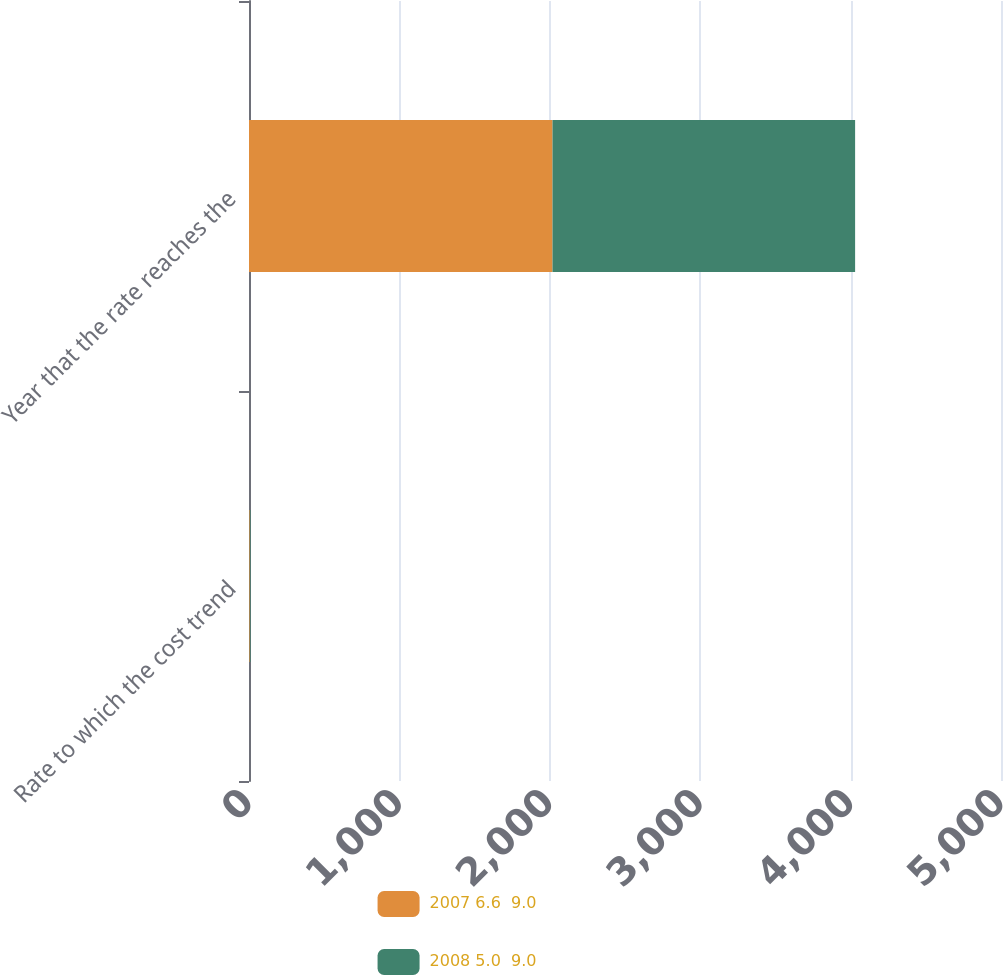<chart> <loc_0><loc_0><loc_500><loc_500><stacked_bar_chart><ecel><fcel>Rate to which the cost trend<fcel>Year that the rate reaches the<nl><fcel>2007 6.6  9.0<fcel>5<fcel>2018<nl><fcel>2008 5.0  9.0<fcel>5<fcel>2012<nl></chart> 